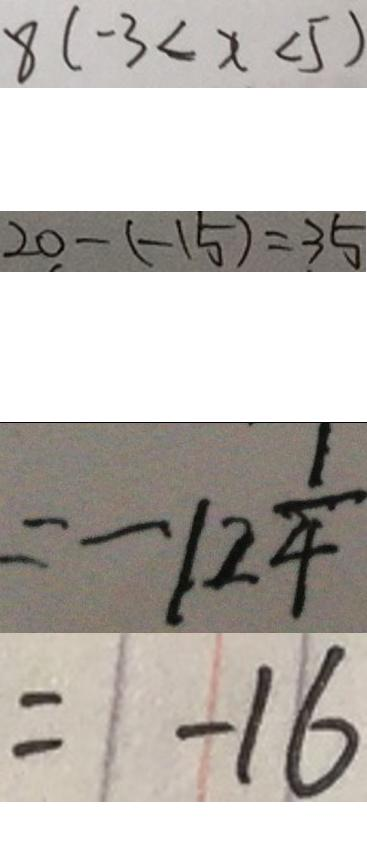<formula> <loc_0><loc_0><loc_500><loc_500>8 ( - 3 < x < 5 ) 
 2 0 - ( - 1 5 ) = 3 5 
 = - 1 2 \frac { 1 } { 4 } 
 = - 1 6</formula> 